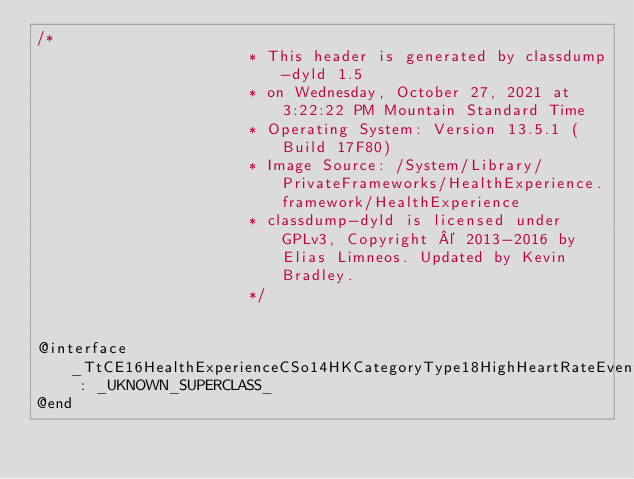<code> <loc_0><loc_0><loc_500><loc_500><_C_>/*
                       * This header is generated by classdump-dyld 1.5
                       * on Wednesday, October 27, 2021 at 3:22:22 PM Mountain Standard Time
                       * Operating System: Version 13.5.1 (Build 17F80)
                       * Image Source: /System/Library/PrivateFrameworks/HealthExperience.framework/HealthExperience
                       * classdump-dyld is licensed under GPLv3, Copyright © 2013-2016 by Elias Limneos. Updated by Kevin Bradley.
                       */


@interface _TtCE16HealthExperienceCSo14HKCategoryType18HighHeartRateEvent : _UKNOWN_SUPERCLASS_
@end

</code> 